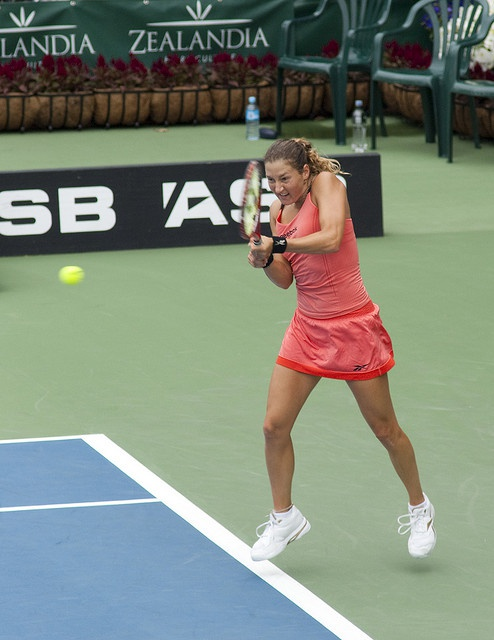Describe the objects in this image and their specific colors. I can see people in black, brown, salmon, and lightgray tones, chair in black and teal tones, chair in black, teal, and gray tones, chair in black, teal, and gray tones, and tennis racket in black, darkgray, lightgray, gray, and beige tones in this image. 